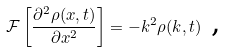Convert formula to latex. <formula><loc_0><loc_0><loc_500><loc_500>\mathcal { F } \left [ \frac { \partial ^ { 2 } \rho ( x , t ) } { \partial x ^ { 2 } } \right ] = - k ^ { 2 } \rho ( k , t ) \text { ,}</formula> 